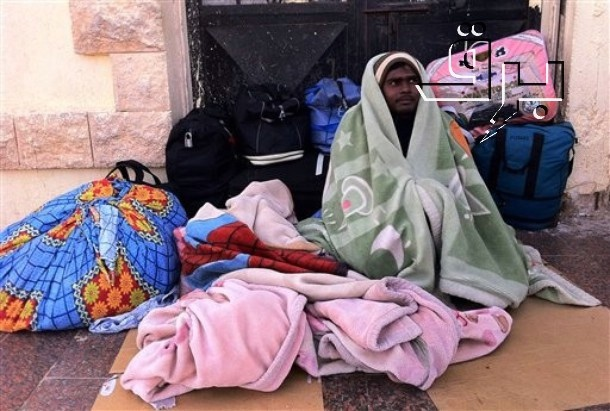Describe the objects in this image and their specific colors. I can see people in ivory, darkgray, gray, black, and lightgray tones, backpack in ivory, black, navy, darkblue, and blue tones, backpack in ivory, black, gray, darkgray, and lightgray tones, and backpack in ivory, black, gray, and darkgray tones in this image. 